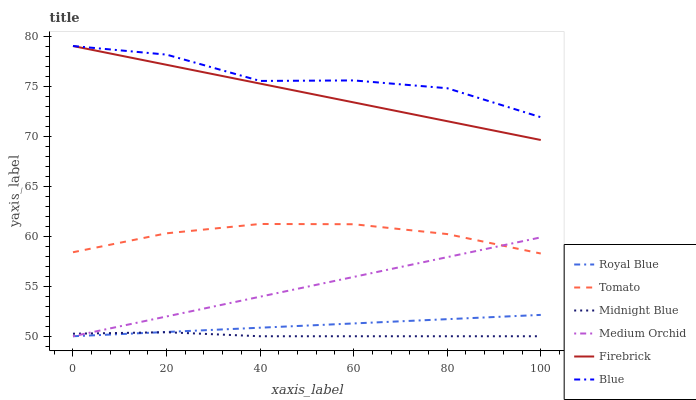Does Midnight Blue have the minimum area under the curve?
Answer yes or no. Yes. Does Blue have the maximum area under the curve?
Answer yes or no. Yes. Does Blue have the minimum area under the curve?
Answer yes or no. No. Does Midnight Blue have the maximum area under the curve?
Answer yes or no. No. Is Firebrick the smoothest?
Answer yes or no. Yes. Is Blue the roughest?
Answer yes or no. Yes. Is Midnight Blue the smoothest?
Answer yes or no. No. Is Midnight Blue the roughest?
Answer yes or no. No. Does Midnight Blue have the lowest value?
Answer yes or no. Yes. Does Blue have the lowest value?
Answer yes or no. No. Does Firebrick have the highest value?
Answer yes or no. Yes. Does Midnight Blue have the highest value?
Answer yes or no. No. Is Midnight Blue less than Blue?
Answer yes or no. Yes. Is Firebrick greater than Tomato?
Answer yes or no. Yes. Does Midnight Blue intersect Medium Orchid?
Answer yes or no. Yes. Is Midnight Blue less than Medium Orchid?
Answer yes or no. No. Is Midnight Blue greater than Medium Orchid?
Answer yes or no. No. Does Midnight Blue intersect Blue?
Answer yes or no. No. 